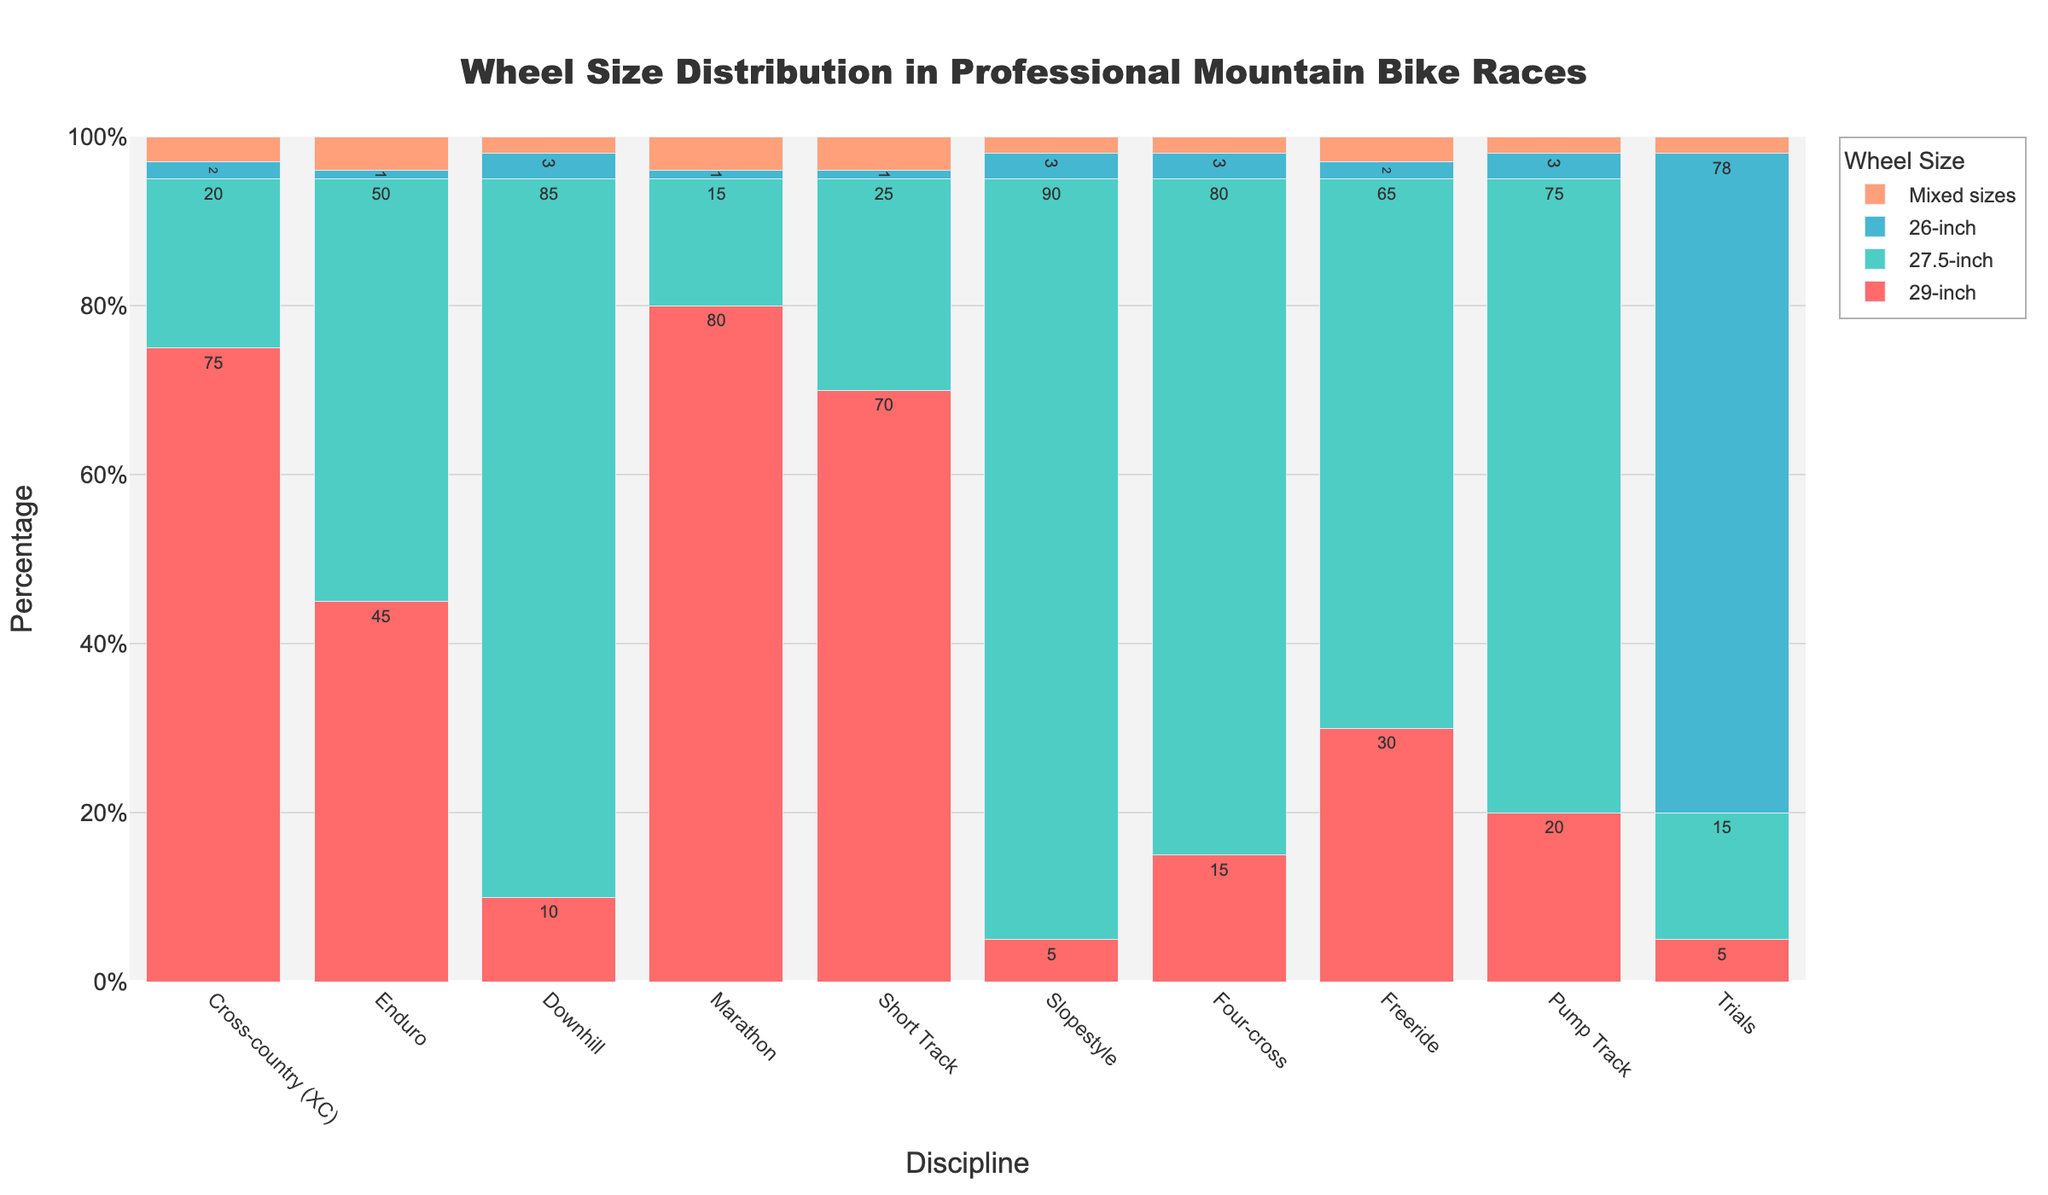What is the most common wheel size for Cross-country (XC) races? By looking at the bar for Cross-country (XC) discipline, we notice that the 29-inch wheel size bar has the highest height, indicating the highest count.
Answer: 29-inch Which discipline has the highest proportion of 26-inch wheels? By comparing the heights of the 26-inch wheel size bars across all disciplines, we see that the Trials discipline has the tallest bar for this wheel size.
Answer: Trials What is the total percentage of mixed sizes in Marathon and Short Track races combined? The mixed sizes percentage for Marathon is 4%, and for Short Track, it's also 4%. Therefore, the combined percentage is 4% + 4% = 8%.
Answer: 8% Which wheel size is least used in Downhill races? Observing the Downhill discipline, the 26-inch wheel size bar is the shortest, implying it has the least count.
Answer: 26-inch Compare the usage of 27.5-inch wheels between Enduro and Freeride disciplines. Which one is higher? Looking at the 27.5-inch wheel size bars for Enduro and Freeride, we see that the bar for Enduro is taller than that of Freeride, indicating higher usage in Enduro.
Answer: Enduro In which discipline do 29-inch wheels and 27.5-inch wheels have the closest usage percentages? By checking the differences between the heights of 29-inch and 27.5-inch wheel size bars for each discipline, the smallest difference is in Enduro (5%).
Answer: Enduro How many disciplines have less than or equal to 3% mixed sizes? Checking the mixed sizes bars for each discipline, we find that Cross-country (XC), Downhill, Slopestyle, Four-cross, Freeride, Pump Track, and Trials have 3% or less. This gives us 7 disciplines.
Answer: 7 What is the ratio of 29-inch to 26-inch wheels in Cross-country (XC) races? The percentage of 29-inch wheels in Cross-country (XC) is 75%, and 26-inch wheels is 2%. The ratio is 75:2 or simplified, 37.5:1.
Answer: 37.5:1 Which discipline has the highest total percentage for wheel sizes other than 29-inch? Summing the percentages for 27.5-inch, 26-inch, and mixed sizes in each discipline, Slopestyle has the highest combined total of 95%.
Answer: Slopestyle What is the difference in the percentage of 29-inch wheels between Marathon and Short Track? The percentage of 29-inch wheels in Marathon is 80%, and in Short Track is 70%. The difference is 80% - 70% = 10%.
Answer: 10% 